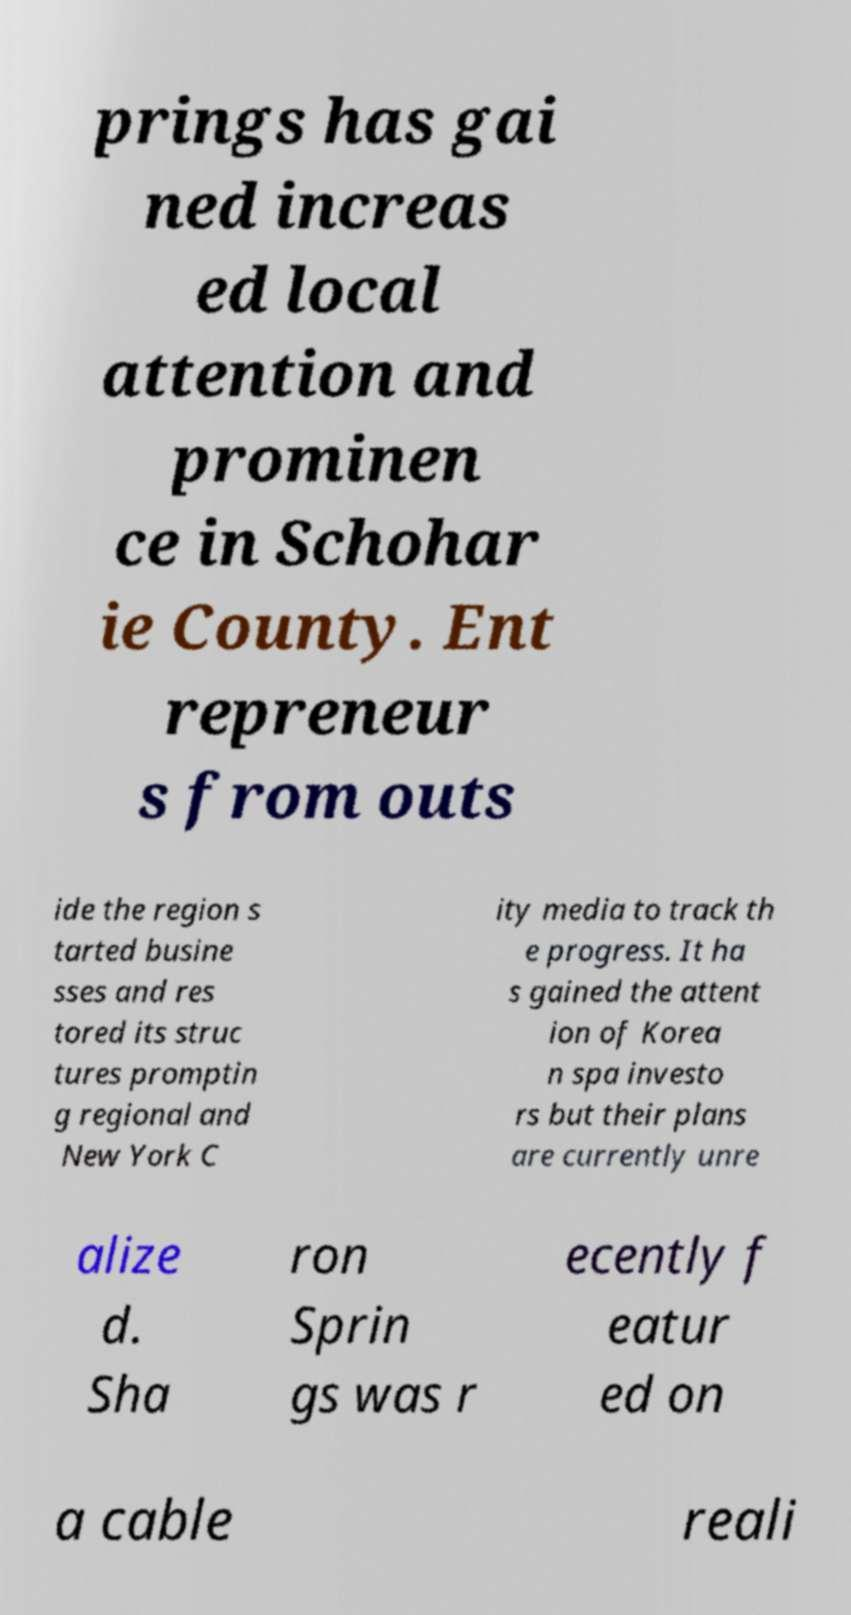Could you extract and type out the text from this image? prings has gai ned increas ed local attention and prominen ce in Schohar ie County. Ent repreneur s from outs ide the region s tarted busine sses and res tored its struc tures promptin g regional and New York C ity media to track th e progress. It ha s gained the attent ion of Korea n spa investo rs but their plans are currently unre alize d. Sha ron Sprin gs was r ecently f eatur ed on a cable reali 